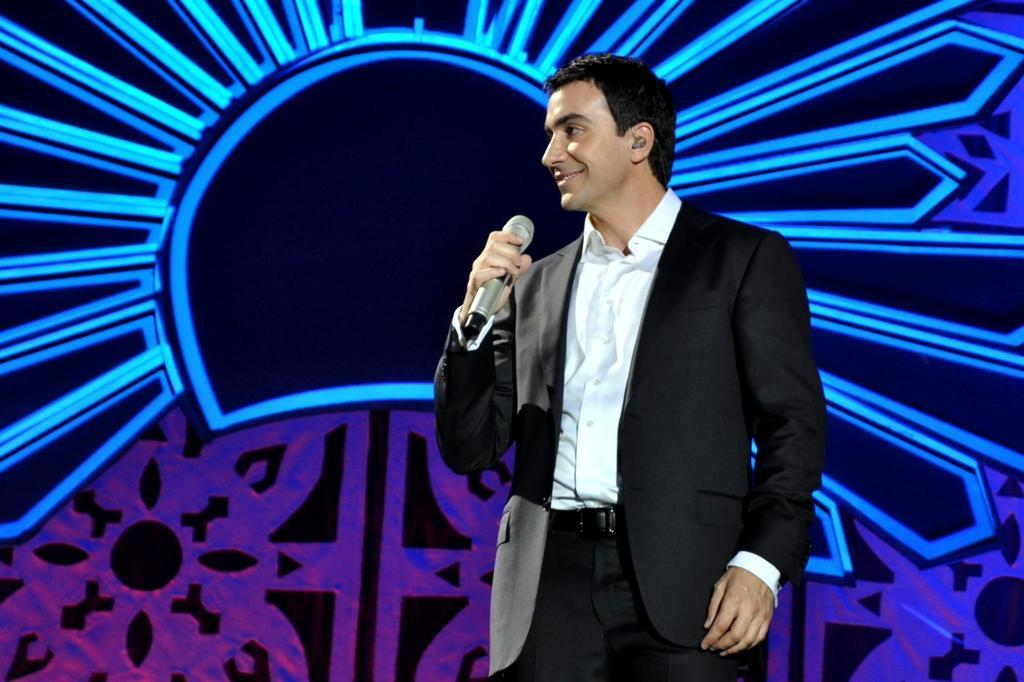What is the person in the image doing? The person is standing in the image. What is the person wearing? The person is wearing a suit. What object is the person holding? The person is holding a microphone. What type of coast can be seen in the background of the image? There is no coast visible in the image; it only features a person standing and holding a microphone. 